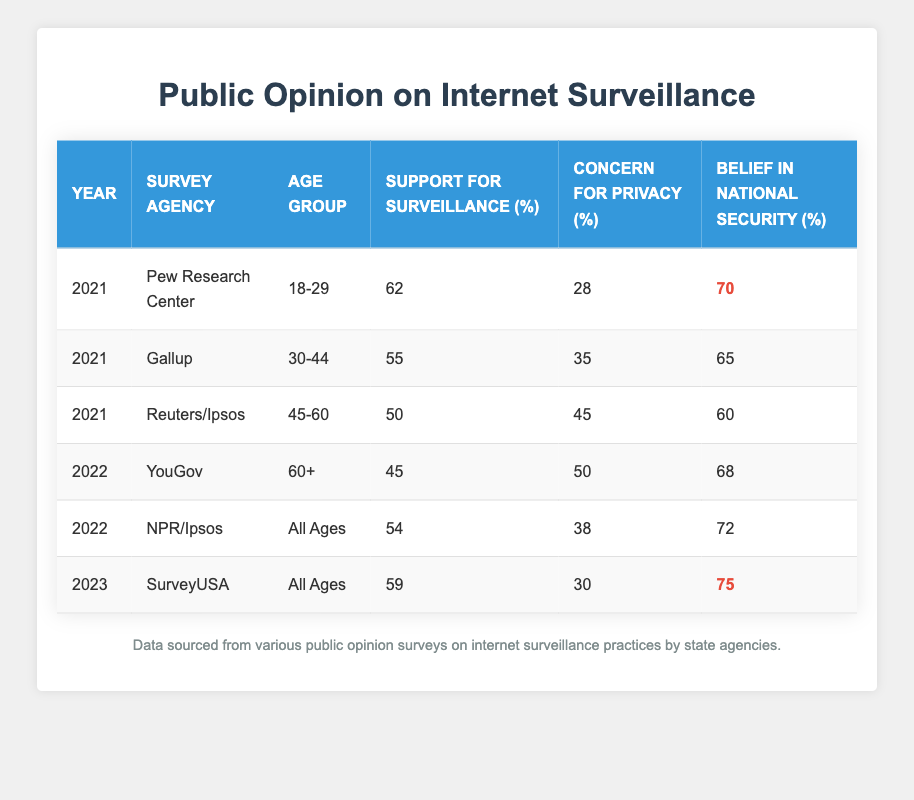What was the support for surveillance among respondents aged 18-29 in 2021? According to the table, the support for surveillance among respondents aged 18-29 in 2021 was specifically listed as 62%.
Answer: 62 Which survey agency reported the highest belief in national security in 2023? In 2023, SurveyUSA reported a belief in national security of 75%, which is the highest value listed in the table for that year.
Answer: SurveyUSA What is the average support for surveillance across all age groups in 2022? To find the average support for surveillance in 2022, we take the support values for both age groups in that year: 45% (YouGov) and 54% (NPR/Ipsos). The average is (45 + 54) / 2 = 49.5%.
Answer: 49.5 Is it true that the concern for privacy decreased from 2021 to 2023 for respondents of all ages? By comparing the concern for privacy from 2021 (38% for NPR/Ipsos and 30% for SurveyUSA in 2023), we see a decrease from 38% to 30%, confirming that it indeed decreased.
Answer: Yes What was the difference in support for surveillance between the youngest (18-29) and oldest (60+) age groups in 2021 and 2022? In 2021, the support for surveillance among the youngest group was 62%, and for the oldest (60+) in 2022, it was 45%. The difference is 62 - 45 = 17%.
Answer: 17 What can be concluded about the trend of belief in national security from 2021 to 2023? In reviewing the data, belief in national security was 70% in 2021 (Pew Research Center), 72% in 2022 (NPR/Ipsos), and rose to 75% in 2023 (SurveyUSA), indicating a steady increase over the three years.
Answer: Increasing trend What was the concern for privacy percentage reported by Reuters/Ipsos in 2021 for the 45-60 age group? The table shows that the concern for privacy reported by Reuters/Ipsos for the 45-60 age group in 2021 was 45%.
Answer: 45 What age group had the lowest support for surveillance in the surveys? From the table, respondents aged 60+ had the lowest support for surveillance at 45% in 2022, making them the least supportive age group.
Answer: 60+ age group Which year had the highest overall belief in national security according to the table? The belief in national security was reported as 75% in 2023 (SurveyUSA), which is the highest overall figure when compared to earlier years.
Answer: 2023 